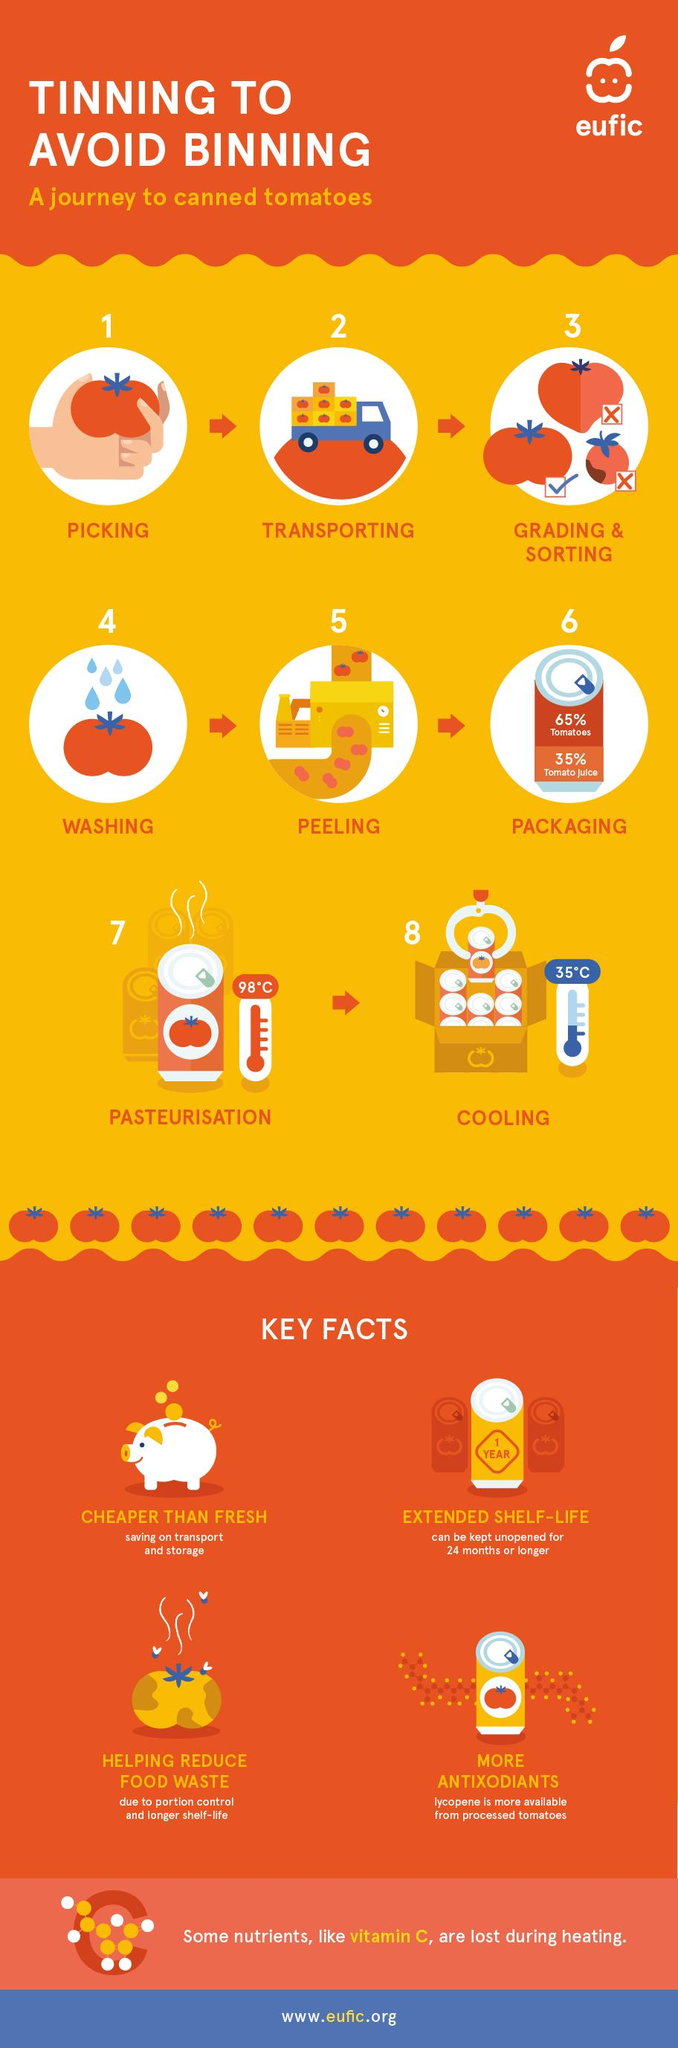Indicate a few pertinent items in this graphic. The percentage of tomatoes written on the can is 65%. The shelf life of canned tomatoes when stored for one year, two years, or more than two years is estimated to be two years or more. It is necessary to cool tomatoes at a temperature of 35 degrees Celsius. The step 6 in canning and tinning tomatoes is packaging. The temperature at which tomatoes must be pasteurized is 100 degrees Celsius. 